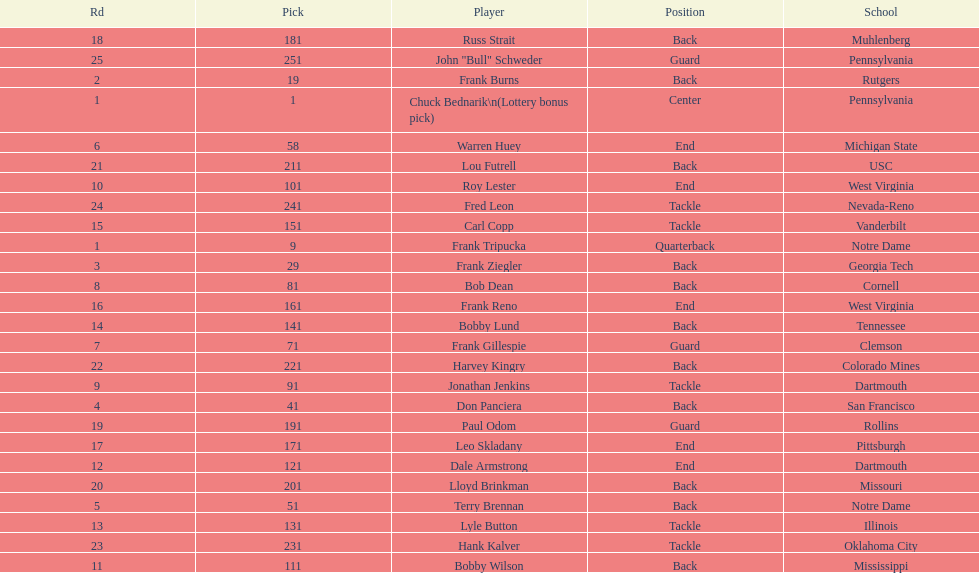Who was picked after roy lester? Bobby Wilson. 